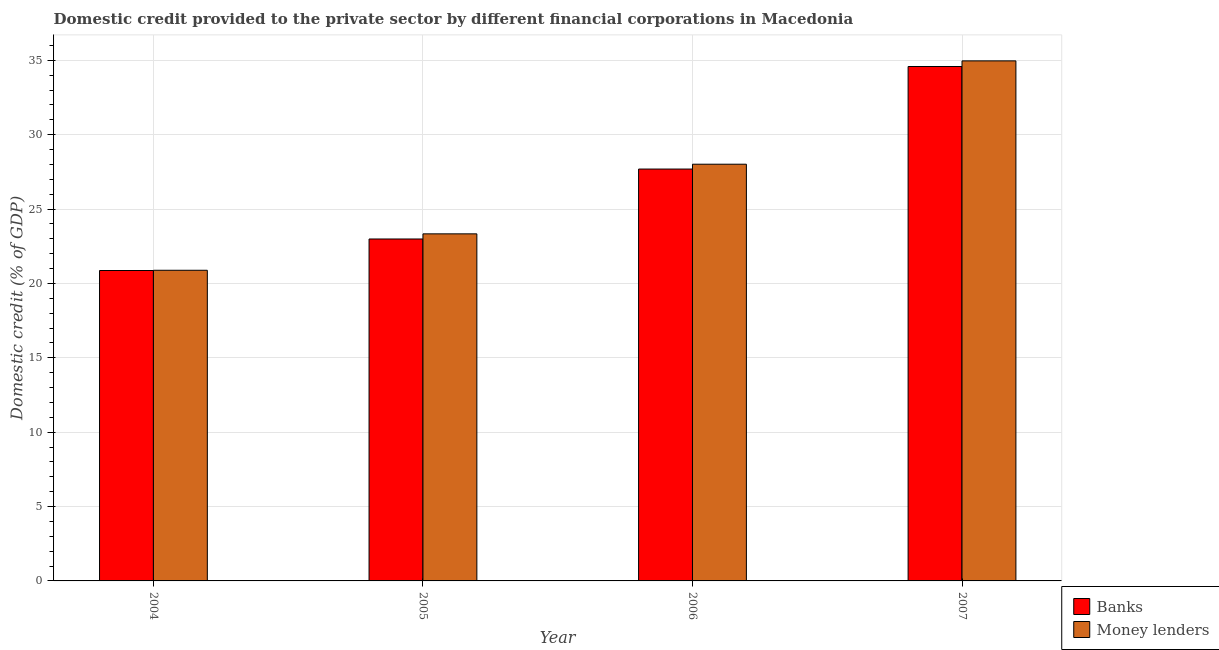How many different coloured bars are there?
Offer a terse response. 2. How many groups of bars are there?
Make the answer very short. 4. How many bars are there on the 4th tick from the left?
Provide a short and direct response. 2. What is the label of the 2nd group of bars from the left?
Provide a short and direct response. 2005. In how many cases, is the number of bars for a given year not equal to the number of legend labels?
Provide a succinct answer. 0. What is the domestic credit provided by banks in 2005?
Keep it short and to the point. 22.99. Across all years, what is the maximum domestic credit provided by money lenders?
Your response must be concise. 34.96. Across all years, what is the minimum domestic credit provided by money lenders?
Ensure brevity in your answer.  20.88. In which year was the domestic credit provided by money lenders maximum?
Give a very brief answer. 2007. In which year was the domestic credit provided by money lenders minimum?
Offer a very short reply. 2004. What is the total domestic credit provided by money lenders in the graph?
Offer a very short reply. 107.19. What is the difference between the domestic credit provided by money lenders in 2005 and that in 2007?
Your response must be concise. -11.63. What is the difference between the domestic credit provided by money lenders in 2006 and the domestic credit provided by banks in 2007?
Provide a short and direct response. -6.95. What is the average domestic credit provided by money lenders per year?
Ensure brevity in your answer.  26.8. What is the ratio of the domestic credit provided by banks in 2006 to that in 2007?
Your answer should be very brief. 0.8. Is the domestic credit provided by money lenders in 2004 less than that in 2007?
Keep it short and to the point. Yes. What is the difference between the highest and the second highest domestic credit provided by banks?
Your answer should be compact. 6.89. What is the difference between the highest and the lowest domestic credit provided by money lenders?
Provide a succinct answer. 14.08. In how many years, is the domestic credit provided by money lenders greater than the average domestic credit provided by money lenders taken over all years?
Offer a terse response. 2. What does the 1st bar from the left in 2007 represents?
Provide a short and direct response. Banks. What does the 1st bar from the right in 2006 represents?
Ensure brevity in your answer.  Money lenders. How many bars are there?
Your response must be concise. 8. How many years are there in the graph?
Provide a succinct answer. 4. What is the difference between two consecutive major ticks on the Y-axis?
Keep it short and to the point. 5. Does the graph contain any zero values?
Provide a succinct answer. No. Does the graph contain grids?
Offer a terse response. Yes. Where does the legend appear in the graph?
Keep it short and to the point. Bottom right. What is the title of the graph?
Your answer should be compact. Domestic credit provided to the private sector by different financial corporations in Macedonia. Does "% of GNI" appear as one of the legend labels in the graph?
Provide a short and direct response. No. What is the label or title of the Y-axis?
Your answer should be very brief. Domestic credit (% of GDP). What is the Domestic credit (% of GDP) in Banks in 2004?
Offer a terse response. 20.87. What is the Domestic credit (% of GDP) in Money lenders in 2004?
Your answer should be very brief. 20.88. What is the Domestic credit (% of GDP) of Banks in 2005?
Your answer should be compact. 22.99. What is the Domestic credit (% of GDP) in Money lenders in 2005?
Offer a terse response. 23.33. What is the Domestic credit (% of GDP) of Banks in 2006?
Offer a terse response. 27.69. What is the Domestic credit (% of GDP) of Money lenders in 2006?
Offer a very short reply. 28.01. What is the Domestic credit (% of GDP) of Banks in 2007?
Make the answer very short. 34.58. What is the Domestic credit (% of GDP) in Money lenders in 2007?
Make the answer very short. 34.96. Across all years, what is the maximum Domestic credit (% of GDP) in Banks?
Offer a very short reply. 34.58. Across all years, what is the maximum Domestic credit (% of GDP) of Money lenders?
Your answer should be very brief. 34.96. Across all years, what is the minimum Domestic credit (% of GDP) in Banks?
Make the answer very short. 20.87. Across all years, what is the minimum Domestic credit (% of GDP) of Money lenders?
Your answer should be very brief. 20.88. What is the total Domestic credit (% of GDP) of Banks in the graph?
Your answer should be compact. 106.13. What is the total Domestic credit (% of GDP) of Money lenders in the graph?
Provide a short and direct response. 107.19. What is the difference between the Domestic credit (% of GDP) in Banks in 2004 and that in 2005?
Offer a very short reply. -2.12. What is the difference between the Domestic credit (% of GDP) in Money lenders in 2004 and that in 2005?
Your answer should be very brief. -2.45. What is the difference between the Domestic credit (% of GDP) of Banks in 2004 and that in 2006?
Offer a very short reply. -6.82. What is the difference between the Domestic credit (% of GDP) of Money lenders in 2004 and that in 2006?
Offer a terse response. -7.13. What is the difference between the Domestic credit (% of GDP) in Banks in 2004 and that in 2007?
Your answer should be compact. -13.71. What is the difference between the Domestic credit (% of GDP) in Money lenders in 2004 and that in 2007?
Keep it short and to the point. -14.08. What is the difference between the Domestic credit (% of GDP) in Banks in 2005 and that in 2006?
Provide a short and direct response. -4.7. What is the difference between the Domestic credit (% of GDP) of Money lenders in 2005 and that in 2006?
Make the answer very short. -4.68. What is the difference between the Domestic credit (% of GDP) of Banks in 2005 and that in 2007?
Your answer should be very brief. -11.6. What is the difference between the Domestic credit (% of GDP) in Money lenders in 2005 and that in 2007?
Offer a very short reply. -11.63. What is the difference between the Domestic credit (% of GDP) in Banks in 2006 and that in 2007?
Your answer should be very brief. -6.89. What is the difference between the Domestic credit (% of GDP) in Money lenders in 2006 and that in 2007?
Give a very brief answer. -6.95. What is the difference between the Domestic credit (% of GDP) of Banks in 2004 and the Domestic credit (% of GDP) of Money lenders in 2005?
Make the answer very short. -2.46. What is the difference between the Domestic credit (% of GDP) in Banks in 2004 and the Domestic credit (% of GDP) in Money lenders in 2006?
Your answer should be compact. -7.15. What is the difference between the Domestic credit (% of GDP) of Banks in 2004 and the Domestic credit (% of GDP) of Money lenders in 2007?
Offer a very short reply. -14.09. What is the difference between the Domestic credit (% of GDP) in Banks in 2005 and the Domestic credit (% of GDP) in Money lenders in 2006?
Provide a succinct answer. -5.03. What is the difference between the Domestic credit (% of GDP) of Banks in 2005 and the Domestic credit (% of GDP) of Money lenders in 2007?
Provide a short and direct response. -11.97. What is the difference between the Domestic credit (% of GDP) of Banks in 2006 and the Domestic credit (% of GDP) of Money lenders in 2007?
Provide a short and direct response. -7.27. What is the average Domestic credit (% of GDP) of Banks per year?
Make the answer very short. 26.53. What is the average Domestic credit (% of GDP) of Money lenders per year?
Keep it short and to the point. 26.8. In the year 2004, what is the difference between the Domestic credit (% of GDP) of Banks and Domestic credit (% of GDP) of Money lenders?
Provide a succinct answer. -0.02. In the year 2005, what is the difference between the Domestic credit (% of GDP) in Banks and Domestic credit (% of GDP) in Money lenders?
Ensure brevity in your answer.  -0.34. In the year 2006, what is the difference between the Domestic credit (% of GDP) of Banks and Domestic credit (% of GDP) of Money lenders?
Keep it short and to the point. -0.33. In the year 2007, what is the difference between the Domestic credit (% of GDP) of Banks and Domestic credit (% of GDP) of Money lenders?
Offer a very short reply. -0.38. What is the ratio of the Domestic credit (% of GDP) in Banks in 2004 to that in 2005?
Provide a succinct answer. 0.91. What is the ratio of the Domestic credit (% of GDP) in Money lenders in 2004 to that in 2005?
Ensure brevity in your answer.  0.9. What is the ratio of the Domestic credit (% of GDP) of Banks in 2004 to that in 2006?
Give a very brief answer. 0.75. What is the ratio of the Domestic credit (% of GDP) in Money lenders in 2004 to that in 2006?
Your response must be concise. 0.75. What is the ratio of the Domestic credit (% of GDP) in Banks in 2004 to that in 2007?
Your response must be concise. 0.6. What is the ratio of the Domestic credit (% of GDP) of Money lenders in 2004 to that in 2007?
Keep it short and to the point. 0.6. What is the ratio of the Domestic credit (% of GDP) in Banks in 2005 to that in 2006?
Provide a succinct answer. 0.83. What is the ratio of the Domestic credit (% of GDP) in Money lenders in 2005 to that in 2006?
Your answer should be compact. 0.83. What is the ratio of the Domestic credit (% of GDP) of Banks in 2005 to that in 2007?
Ensure brevity in your answer.  0.66. What is the ratio of the Domestic credit (% of GDP) of Money lenders in 2005 to that in 2007?
Offer a terse response. 0.67. What is the ratio of the Domestic credit (% of GDP) in Banks in 2006 to that in 2007?
Your answer should be very brief. 0.8. What is the ratio of the Domestic credit (% of GDP) of Money lenders in 2006 to that in 2007?
Your answer should be very brief. 0.8. What is the difference between the highest and the second highest Domestic credit (% of GDP) in Banks?
Your response must be concise. 6.89. What is the difference between the highest and the second highest Domestic credit (% of GDP) of Money lenders?
Give a very brief answer. 6.95. What is the difference between the highest and the lowest Domestic credit (% of GDP) of Banks?
Give a very brief answer. 13.71. What is the difference between the highest and the lowest Domestic credit (% of GDP) in Money lenders?
Ensure brevity in your answer.  14.08. 